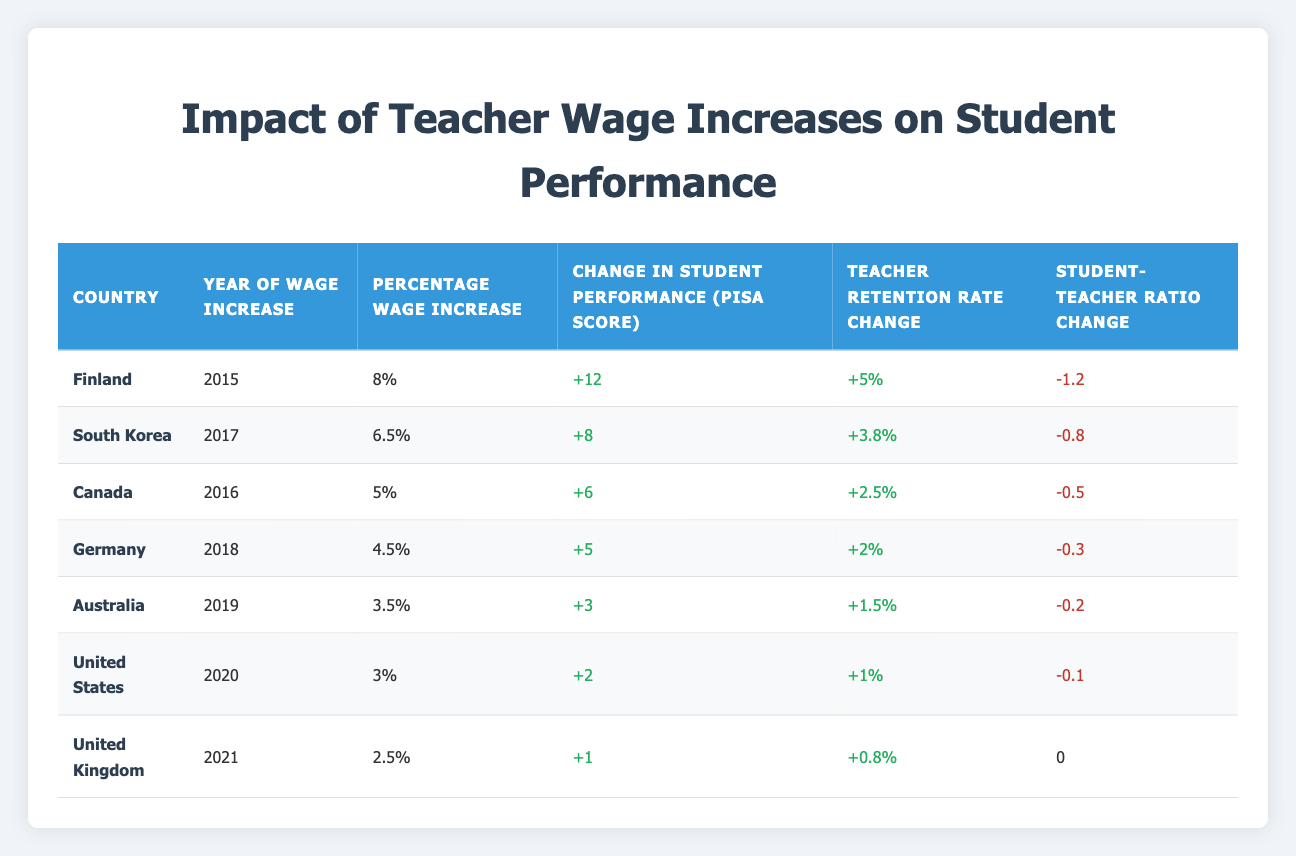What was the percentage wage increase in Finland? Looking at the table, the percentage wage increase for Finland is found in the corresponding row under "Percentage Wage Increase," which states "8%."
Answer: 8% Which country had the highest change in student performance? Referring to the "Change in Student Performance (PISA Score)" column, Finland shows the highest increase with "+12" PISA points compared to the other countries listed.
Answer: Finland What was the average change in student performance across these countries? To find the average, we sum the "Change in Student Performance (PISA Score)" values: 12 + 8 + 6 + 5 + 3 + 2 + 1 = 37 over 7 countries, which gives an average of 37/7 = 5.29.
Answer: 5.29 Did Germany experience an increase in its teacher retention rate after the wage increase? By checking the "Teacher Retention Rate Change" for Germany, we see it is "+2%," indicating a positive change. Therefore, the statement is true.
Answer: Yes What is the difference in student performance change between the countries with the highest and lowest wage increases? The highest is Finland with "+12" and the lowest is the United Kingdom with "+1." The difference is calculated as 12 - 1 = 11.
Answer: 11 Which country had the lowest change in teacher retention rate, and what was that change? In the table, the lowest change in teacher retention rate is seen in the United Kingdom with a change of "+0.8%."
Answer: United Kingdom, +0.8% Did the United States have a decrease in its student-teacher ratio after the wage increase? The "Student-Teacher Ratio Change" for the United States shows "-0.1," which indicates a decrease in the ratio.
Answer: Yes How did the percentage wage increase in Australia compare to that in Canada? Australia had a wage increase of "3.5%" and Canada had "5%." Since 5% is greater than 3.5%, Canada’s increase was higher.
Answer: Canada’s was higher 